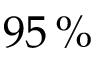<formula> <loc_0><loc_0><loc_500><loc_500>9 5 \, \%</formula> 